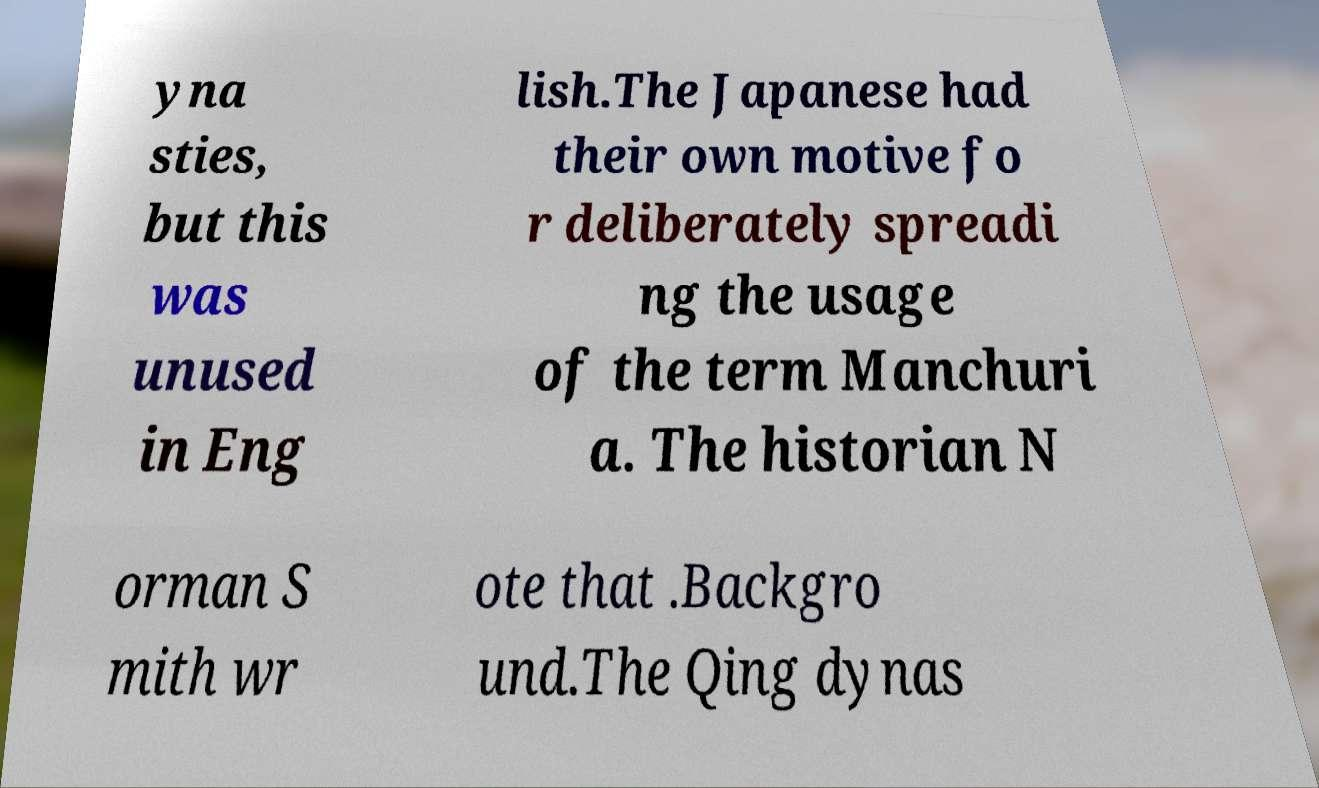What messages or text are displayed in this image? I need them in a readable, typed format. yna sties, but this was unused in Eng lish.The Japanese had their own motive fo r deliberately spreadi ng the usage of the term Manchuri a. The historian N orman S mith wr ote that .Backgro und.The Qing dynas 